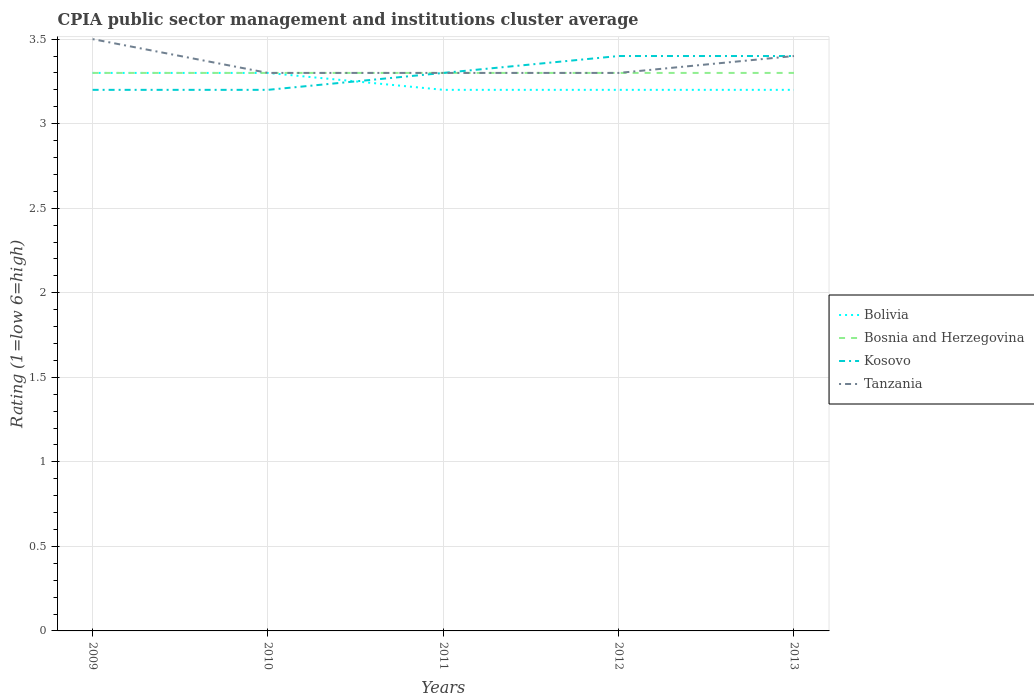How many different coloured lines are there?
Your answer should be very brief. 4. Does the line corresponding to Bolivia intersect with the line corresponding to Bosnia and Herzegovina?
Keep it short and to the point. Yes. Across all years, what is the maximum CPIA rating in Bosnia and Herzegovina?
Keep it short and to the point. 3.3. In which year was the CPIA rating in Kosovo maximum?
Provide a short and direct response. 2009. What is the total CPIA rating in Bolivia in the graph?
Make the answer very short. 0.1. What is the difference between the highest and the second highest CPIA rating in Tanzania?
Offer a terse response. 0.2. What is the difference between the highest and the lowest CPIA rating in Bolivia?
Offer a terse response. 2. Does the graph contain any zero values?
Keep it short and to the point. No. Does the graph contain grids?
Give a very brief answer. Yes. How many legend labels are there?
Offer a terse response. 4. How are the legend labels stacked?
Your answer should be compact. Vertical. What is the title of the graph?
Make the answer very short. CPIA public sector management and institutions cluster average. Does "High income: nonOECD" appear as one of the legend labels in the graph?
Your answer should be compact. No. What is the label or title of the Y-axis?
Provide a short and direct response. Rating (1=low 6=high). What is the Rating (1=low 6=high) in Bolivia in 2009?
Your answer should be very brief. 3.3. What is the Rating (1=low 6=high) of Bolivia in 2010?
Give a very brief answer. 3.3. What is the Rating (1=low 6=high) in Tanzania in 2010?
Provide a succinct answer. 3.3. What is the Rating (1=low 6=high) in Bolivia in 2011?
Provide a short and direct response. 3.2. What is the Rating (1=low 6=high) in Bosnia and Herzegovina in 2011?
Provide a short and direct response. 3.3. What is the Rating (1=low 6=high) of Kosovo in 2011?
Keep it short and to the point. 3.3. What is the Rating (1=low 6=high) of Tanzania in 2011?
Make the answer very short. 3.3. What is the Rating (1=low 6=high) of Bosnia and Herzegovina in 2012?
Make the answer very short. 3.3. What is the Rating (1=low 6=high) of Kosovo in 2012?
Provide a succinct answer. 3.4. What is the Rating (1=low 6=high) of Bosnia and Herzegovina in 2013?
Ensure brevity in your answer.  3.3. What is the Rating (1=low 6=high) of Kosovo in 2013?
Offer a very short reply. 3.4. What is the Rating (1=low 6=high) in Tanzania in 2013?
Offer a very short reply. 3.4. Across all years, what is the minimum Rating (1=low 6=high) of Bosnia and Herzegovina?
Your response must be concise. 3.3. Across all years, what is the minimum Rating (1=low 6=high) of Tanzania?
Offer a very short reply. 3.3. What is the total Rating (1=low 6=high) in Bolivia in the graph?
Ensure brevity in your answer.  16.2. What is the total Rating (1=low 6=high) of Kosovo in the graph?
Offer a very short reply. 16.5. What is the difference between the Rating (1=low 6=high) in Bosnia and Herzegovina in 2009 and that in 2010?
Offer a very short reply. 0. What is the difference between the Rating (1=low 6=high) of Tanzania in 2009 and that in 2010?
Your answer should be very brief. 0.2. What is the difference between the Rating (1=low 6=high) in Bolivia in 2009 and that in 2012?
Keep it short and to the point. 0.1. What is the difference between the Rating (1=low 6=high) of Bosnia and Herzegovina in 2009 and that in 2012?
Make the answer very short. 0. What is the difference between the Rating (1=low 6=high) in Bolivia in 2009 and that in 2013?
Keep it short and to the point. 0.1. What is the difference between the Rating (1=low 6=high) in Bosnia and Herzegovina in 2009 and that in 2013?
Make the answer very short. 0. What is the difference between the Rating (1=low 6=high) in Kosovo in 2009 and that in 2013?
Your answer should be compact. -0.2. What is the difference between the Rating (1=low 6=high) of Tanzania in 2009 and that in 2013?
Offer a very short reply. 0.1. What is the difference between the Rating (1=low 6=high) of Bolivia in 2010 and that in 2011?
Your answer should be compact. 0.1. What is the difference between the Rating (1=low 6=high) in Bosnia and Herzegovina in 2010 and that in 2012?
Give a very brief answer. 0. What is the difference between the Rating (1=low 6=high) of Kosovo in 2010 and that in 2012?
Your answer should be compact. -0.2. What is the difference between the Rating (1=low 6=high) in Tanzania in 2010 and that in 2012?
Offer a very short reply. 0. What is the difference between the Rating (1=low 6=high) in Bolivia in 2011 and that in 2013?
Offer a terse response. 0. What is the difference between the Rating (1=low 6=high) in Bosnia and Herzegovina in 2011 and that in 2013?
Make the answer very short. 0. What is the difference between the Rating (1=low 6=high) in Tanzania in 2011 and that in 2013?
Ensure brevity in your answer.  -0.1. What is the difference between the Rating (1=low 6=high) of Bolivia in 2012 and that in 2013?
Keep it short and to the point. 0. What is the difference between the Rating (1=low 6=high) of Bosnia and Herzegovina in 2012 and that in 2013?
Your response must be concise. 0. What is the difference between the Rating (1=low 6=high) in Bolivia in 2009 and the Rating (1=low 6=high) in Bosnia and Herzegovina in 2010?
Your answer should be compact. 0. What is the difference between the Rating (1=low 6=high) in Bolivia in 2009 and the Rating (1=low 6=high) in Tanzania in 2010?
Provide a succinct answer. 0. What is the difference between the Rating (1=low 6=high) of Bosnia and Herzegovina in 2009 and the Rating (1=low 6=high) of Kosovo in 2010?
Offer a very short reply. 0.1. What is the difference between the Rating (1=low 6=high) of Bolivia in 2009 and the Rating (1=low 6=high) of Bosnia and Herzegovina in 2011?
Provide a succinct answer. 0. What is the difference between the Rating (1=low 6=high) of Bolivia in 2009 and the Rating (1=low 6=high) of Kosovo in 2011?
Offer a very short reply. 0. What is the difference between the Rating (1=low 6=high) of Bosnia and Herzegovina in 2009 and the Rating (1=low 6=high) of Kosovo in 2011?
Ensure brevity in your answer.  0. What is the difference between the Rating (1=low 6=high) in Bosnia and Herzegovina in 2009 and the Rating (1=low 6=high) in Tanzania in 2011?
Offer a very short reply. 0. What is the difference between the Rating (1=low 6=high) in Bolivia in 2009 and the Rating (1=low 6=high) in Tanzania in 2012?
Provide a succinct answer. 0. What is the difference between the Rating (1=low 6=high) in Bosnia and Herzegovina in 2009 and the Rating (1=low 6=high) in Kosovo in 2012?
Ensure brevity in your answer.  -0.1. What is the difference between the Rating (1=low 6=high) of Kosovo in 2009 and the Rating (1=low 6=high) of Tanzania in 2012?
Keep it short and to the point. -0.1. What is the difference between the Rating (1=low 6=high) in Bolivia in 2009 and the Rating (1=low 6=high) in Kosovo in 2013?
Keep it short and to the point. -0.1. What is the difference between the Rating (1=low 6=high) in Bosnia and Herzegovina in 2009 and the Rating (1=low 6=high) in Kosovo in 2013?
Offer a terse response. -0.1. What is the difference between the Rating (1=low 6=high) in Bosnia and Herzegovina in 2009 and the Rating (1=low 6=high) in Tanzania in 2013?
Your answer should be very brief. -0.1. What is the difference between the Rating (1=low 6=high) of Kosovo in 2009 and the Rating (1=low 6=high) of Tanzania in 2013?
Your answer should be very brief. -0.2. What is the difference between the Rating (1=low 6=high) in Bolivia in 2010 and the Rating (1=low 6=high) in Kosovo in 2011?
Offer a very short reply. 0. What is the difference between the Rating (1=low 6=high) in Bolivia in 2010 and the Rating (1=low 6=high) in Tanzania in 2011?
Your answer should be compact. 0. What is the difference between the Rating (1=low 6=high) of Bosnia and Herzegovina in 2010 and the Rating (1=low 6=high) of Kosovo in 2011?
Keep it short and to the point. 0. What is the difference between the Rating (1=low 6=high) of Kosovo in 2010 and the Rating (1=low 6=high) of Tanzania in 2011?
Give a very brief answer. -0.1. What is the difference between the Rating (1=low 6=high) in Bolivia in 2010 and the Rating (1=low 6=high) in Tanzania in 2012?
Your answer should be compact. 0. What is the difference between the Rating (1=low 6=high) of Bosnia and Herzegovina in 2010 and the Rating (1=low 6=high) of Kosovo in 2012?
Ensure brevity in your answer.  -0.1. What is the difference between the Rating (1=low 6=high) of Bolivia in 2010 and the Rating (1=low 6=high) of Bosnia and Herzegovina in 2013?
Your answer should be compact. 0. What is the difference between the Rating (1=low 6=high) of Bolivia in 2010 and the Rating (1=low 6=high) of Kosovo in 2013?
Your answer should be very brief. -0.1. What is the difference between the Rating (1=low 6=high) of Bolivia in 2010 and the Rating (1=low 6=high) of Tanzania in 2013?
Provide a succinct answer. -0.1. What is the difference between the Rating (1=low 6=high) in Bosnia and Herzegovina in 2010 and the Rating (1=low 6=high) in Kosovo in 2013?
Ensure brevity in your answer.  -0.1. What is the difference between the Rating (1=low 6=high) of Bolivia in 2011 and the Rating (1=low 6=high) of Bosnia and Herzegovina in 2012?
Make the answer very short. -0.1. What is the difference between the Rating (1=low 6=high) in Bosnia and Herzegovina in 2011 and the Rating (1=low 6=high) in Tanzania in 2012?
Keep it short and to the point. 0. What is the difference between the Rating (1=low 6=high) in Bolivia in 2011 and the Rating (1=low 6=high) in Tanzania in 2013?
Give a very brief answer. -0.2. What is the difference between the Rating (1=low 6=high) of Bosnia and Herzegovina in 2011 and the Rating (1=low 6=high) of Tanzania in 2013?
Make the answer very short. -0.1. What is the difference between the Rating (1=low 6=high) of Bosnia and Herzegovina in 2012 and the Rating (1=low 6=high) of Kosovo in 2013?
Your answer should be compact. -0.1. What is the difference between the Rating (1=low 6=high) in Bosnia and Herzegovina in 2012 and the Rating (1=low 6=high) in Tanzania in 2013?
Provide a succinct answer. -0.1. What is the average Rating (1=low 6=high) in Bolivia per year?
Your response must be concise. 3.24. What is the average Rating (1=low 6=high) of Kosovo per year?
Provide a short and direct response. 3.3. What is the average Rating (1=low 6=high) in Tanzania per year?
Offer a terse response. 3.36. In the year 2009, what is the difference between the Rating (1=low 6=high) in Bolivia and Rating (1=low 6=high) in Bosnia and Herzegovina?
Your answer should be very brief. 0. In the year 2009, what is the difference between the Rating (1=low 6=high) of Bosnia and Herzegovina and Rating (1=low 6=high) of Kosovo?
Ensure brevity in your answer.  0.1. In the year 2009, what is the difference between the Rating (1=low 6=high) in Bosnia and Herzegovina and Rating (1=low 6=high) in Tanzania?
Offer a very short reply. -0.2. In the year 2010, what is the difference between the Rating (1=low 6=high) in Bolivia and Rating (1=low 6=high) in Bosnia and Herzegovina?
Provide a short and direct response. 0. In the year 2010, what is the difference between the Rating (1=low 6=high) in Bosnia and Herzegovina and Rating (1=low 6=high) in Kosovo?
Your answer should be compact. 0.1. In the year 2010, what is the difference between the Rating (1=low 6=high) in Bosnia and Herzegovina and Rating (1=low 6=high) in Tanzania?
Offer a very short reply. 0. In the year 2011, what is the difference between the Rating (1=low 6=high) of Bolivia and Rating (1=low 6=high) of Bosnia and Herzegovina?
Keep it short and to the point. -0.1. In the year 2011, what is the difference between the Rating (1=low 6=high) of Bolivia and Rating (1=low 6=high) of Kosovo?
Your answer should be compact. -0.1. In the year 2011, what is the difference between the Rating (1=low 6=high) in Bolivia and Rating (1=low 6=high) in Tanzania?
Provide a succinct answer. -0.1. In the year 2011, what is the difference between the Rating (1=low 6=high) of Bosnia and Herzegovina and Rating (1=low 6=high) of Kosovo?
Provide a short and direct response. 0. In the year 2012, what is the difference between the Rating (1=low 6=high) of Bolivia and Rating (1=low 6=high) of Bosnia and Herzegovina?
Keep it short and to the point. -0.1. In the year 2012, what is the difference between the Rating (1=low 6=high) in Bosnia and Herzegovina and Rating (1=low 6=high) in Tanzania?
Provide a succinct answer. 0. In the year 2013, what is the difference between the Rating (1=low 6=high) in Bolivia and Rating (1=low 6=high) in Kosovo?
Ensure brevity in your answer.  -0.2. In the year 2013, what is the difference between the Rating (1=low 6=high) in Bolivia and Rating (1=low 6=high) in Tanzania?
Keep it short and to the point. -0.2. In the year 2013, what is the difference between the Rating (1=low 6=high) of Bosnia and Herzegovina and Rating (1=low 6=high) of Tanzania?
Your answer should be very brief. -0.1. In the year 2013, what is the difference between the Rating (1=low 6=high) of Kosovo and Rating (1=low 6=high) of Tanzania?
Make the answer very short. 0. What is the ratio of the Rating (1=low 6=high) of Tanzania in 2009 to that in 2010?
Offer a terse response. 1.06. What is the ratio of the Rating (1=low 6=high) of Bolivia in 2009 to that in 2011?
Your response must be concise. 1.03. What is the ratio of the Rating (1=low 6=high) of Bosnia and Herzegovina in 2009 to that in 2011?
Ensure brevity in your answer.  1. What is the ratio of the Rating (1=low 6=high) in Kosovo in 2009 to that in 2011?
Provide a short and direct response. 0.97. What is the ratio of the Rating (1=low 6=high) of Tanzania in 2009 to that in 2011?
Provide a short and direct response. 1.06. What is the ratio of the Rating (1=low 6=high) of Bolivia in 2009 to that in 2012?
Give a very brief answer. 1.03. What is the ratio of the Rating (1=low 6=high) of Bosnia and Herzegovina in 2009 to that in 2012?
Provide a short and direct response. 1. What is the ratio of the Rating (1=low 6=high) in Kosovo in 2009 to that in 2012?
Give a very brief answer. 0.94. What is the ratio of the Rating (1=low 6=high) of Tanzania in 2009 to that in 2012?
Provide a succinct answer. 1.06. What is the ratio of the Rating (1=low 6=high) in Bolivia in 2009 to that in 2013?
Your response must be concise. 1.03. What is the ratio of the Rating (1=low 6=high) in Bosnia and Herzegovina in 2009 to that in 2013?
Provide a succinct answer. 1. What is the ratio of the Rating (1=low 6=high) in Tanzania in 2009 to that in 2013?
Offer a terse response. 1.03. What is the ratio of the Rating (1=low 6=high) in Bolivia in 2010 to that in 2011?
Ensure brevity in your answer.  1.03. What is the ratio of the Rating (1=low 6=high) of Bosnia and Herzegovina in 2010 to that in 2011?
Provide a succinct answer. 1. What is the ratio of the Rating (1=low 6=high) in Kosovo in 2010 to that in 2011?
Offer a very short reply. 0.97. What is the ratio of the Rating (1=low 6=high) in Bolivia in 2010 to that in 2012?
Give a very brief answer. 1.03. What is the ratio of the Rating (1=low 6=high) of Bosnia and Herzegovina in 2010 to that in 2012?
Keep it short and to the point. 1. What is the ratio of the Rating (1=low 6=high) of Bolivia in 2010 to that in 2013?
Provide a short and direct response. 1.03. What is the ratio of the Rating (1=low 6=high) in Kosovo in 2010 to that in 2013?
Offer a very short reply. 0.94. What is the ratio of the Rating (1=low 6=high) in Tanzania in 2010 to that in 2013?
Provide a short and direct response. 0.97. What is the ratio of the Rating (1=low 6=high) of Bolivia in 2011 to that in 2012?
Provide a succinct answer. 1. What is the ratio of the Rating (1=low 6=high) in Bosnia and Herzegovina in 2011 to that in 2012?
Ensure brevity in your answer.  1. What is the ratio of the Rating (1=low 6=high) of Kosovo in 2011 to that in 2012?
Provide a succinct answer. 0.97. What is the ratio of the Rating (1=low 6=high) in Tanzania in 2011 to that in 2012?
Your answer should be very brief. 1. What is the ratio of the Rating (1=low 6=high) in Kosovo in 2011 to that in 2013?
Provide a succinct answer. 0.97. What is the ratio of the Rating (1=low 6=high) of Tanzania in 2011 to that in 2013?
Your response must be concise. 0.97. What is the ratio of the Rating (1=low 6=high) of Bolivia in 2012 to that in 2013?
Provide a short and direct response. 1. What is the ratio of the Rating (1=low 6=high) in Bosnia and Herzegovina in 2012 to that in 2013?
Your answer should be very brief. 1. What is the ratio of the Rating (1=low 6=high) of Tanzania in 2012 to that in 2013?
Offer a terse response. 0.97. What is the difference between the highest and the second highest Rating (1=low 6=high) in Kosovo?
Ensure brevity in your answer.  0. What is the difference between the highest and the lowest Rating (1=low 6=high) of Bosnia and Herzegovina?
Your answer should be compact. 0. 